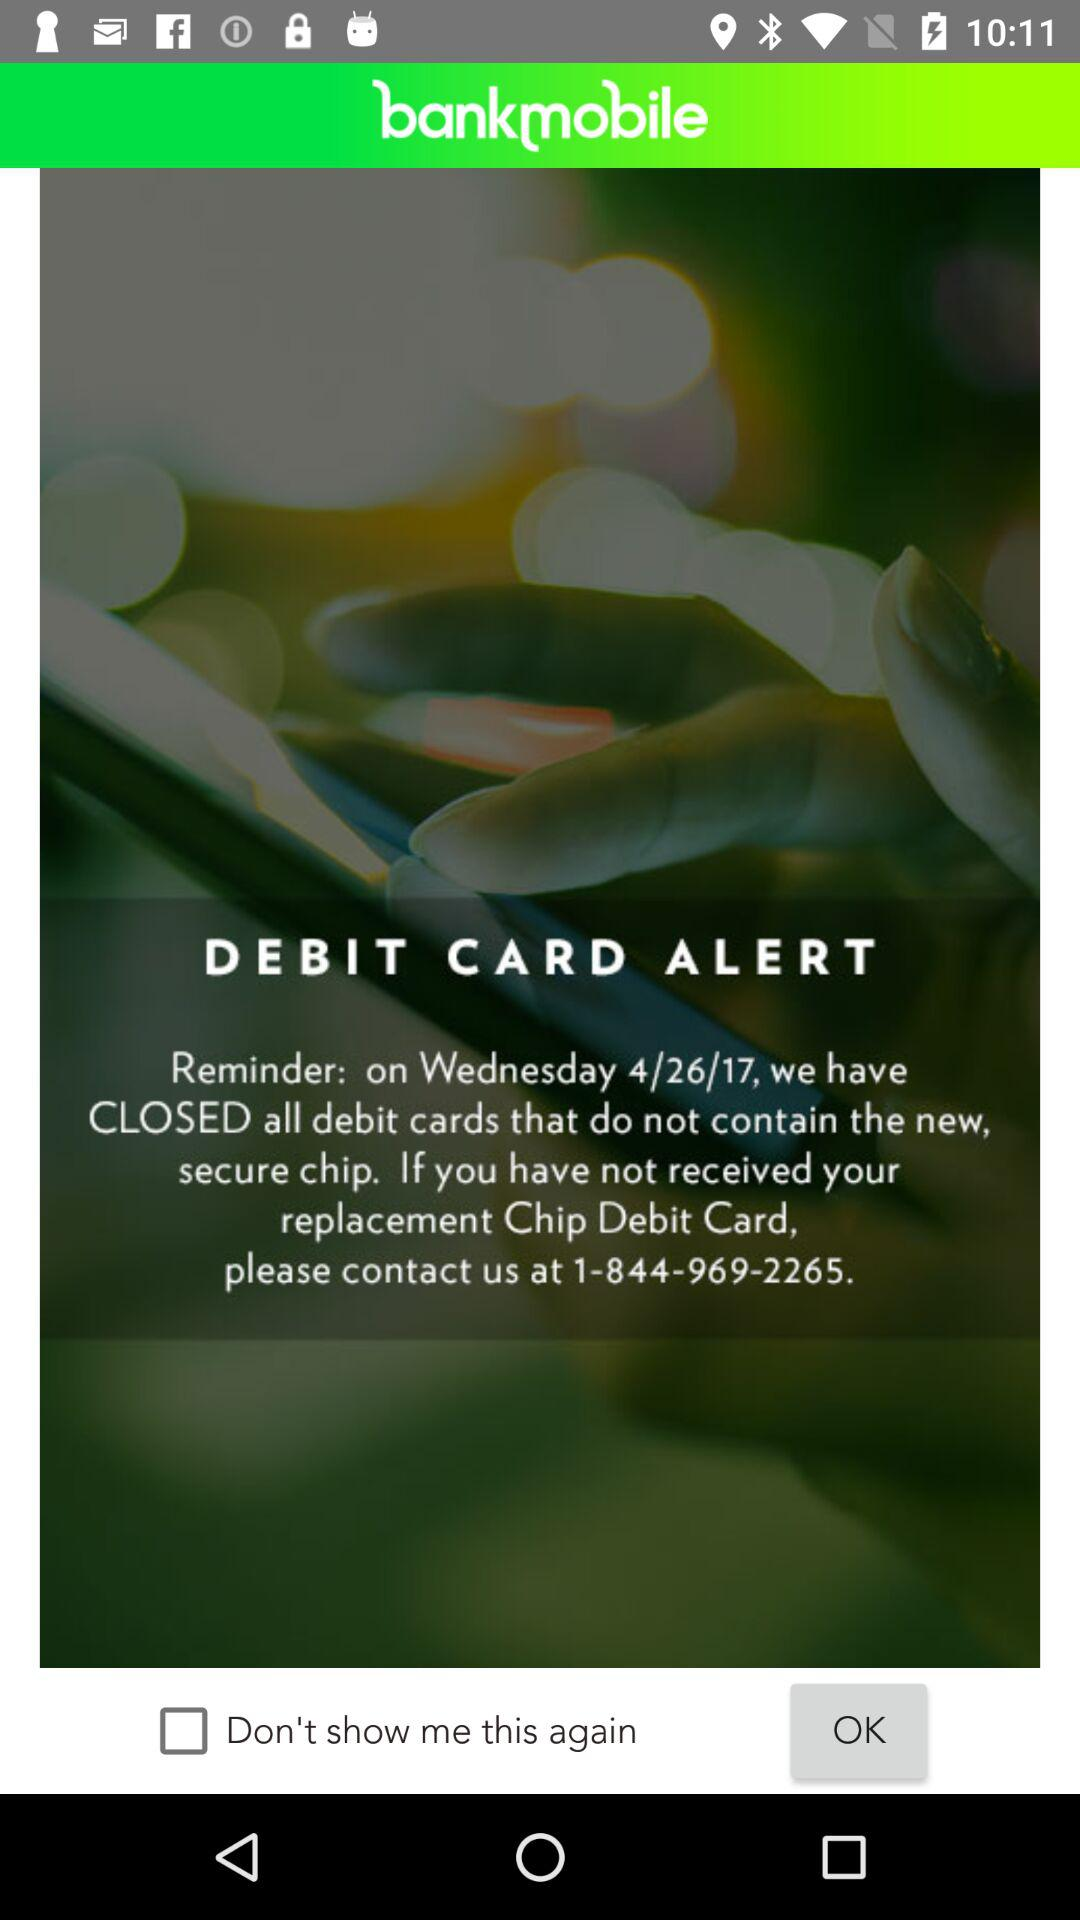What day falls on 4/26/17? Day on 4/26/17 is Wednesday. 